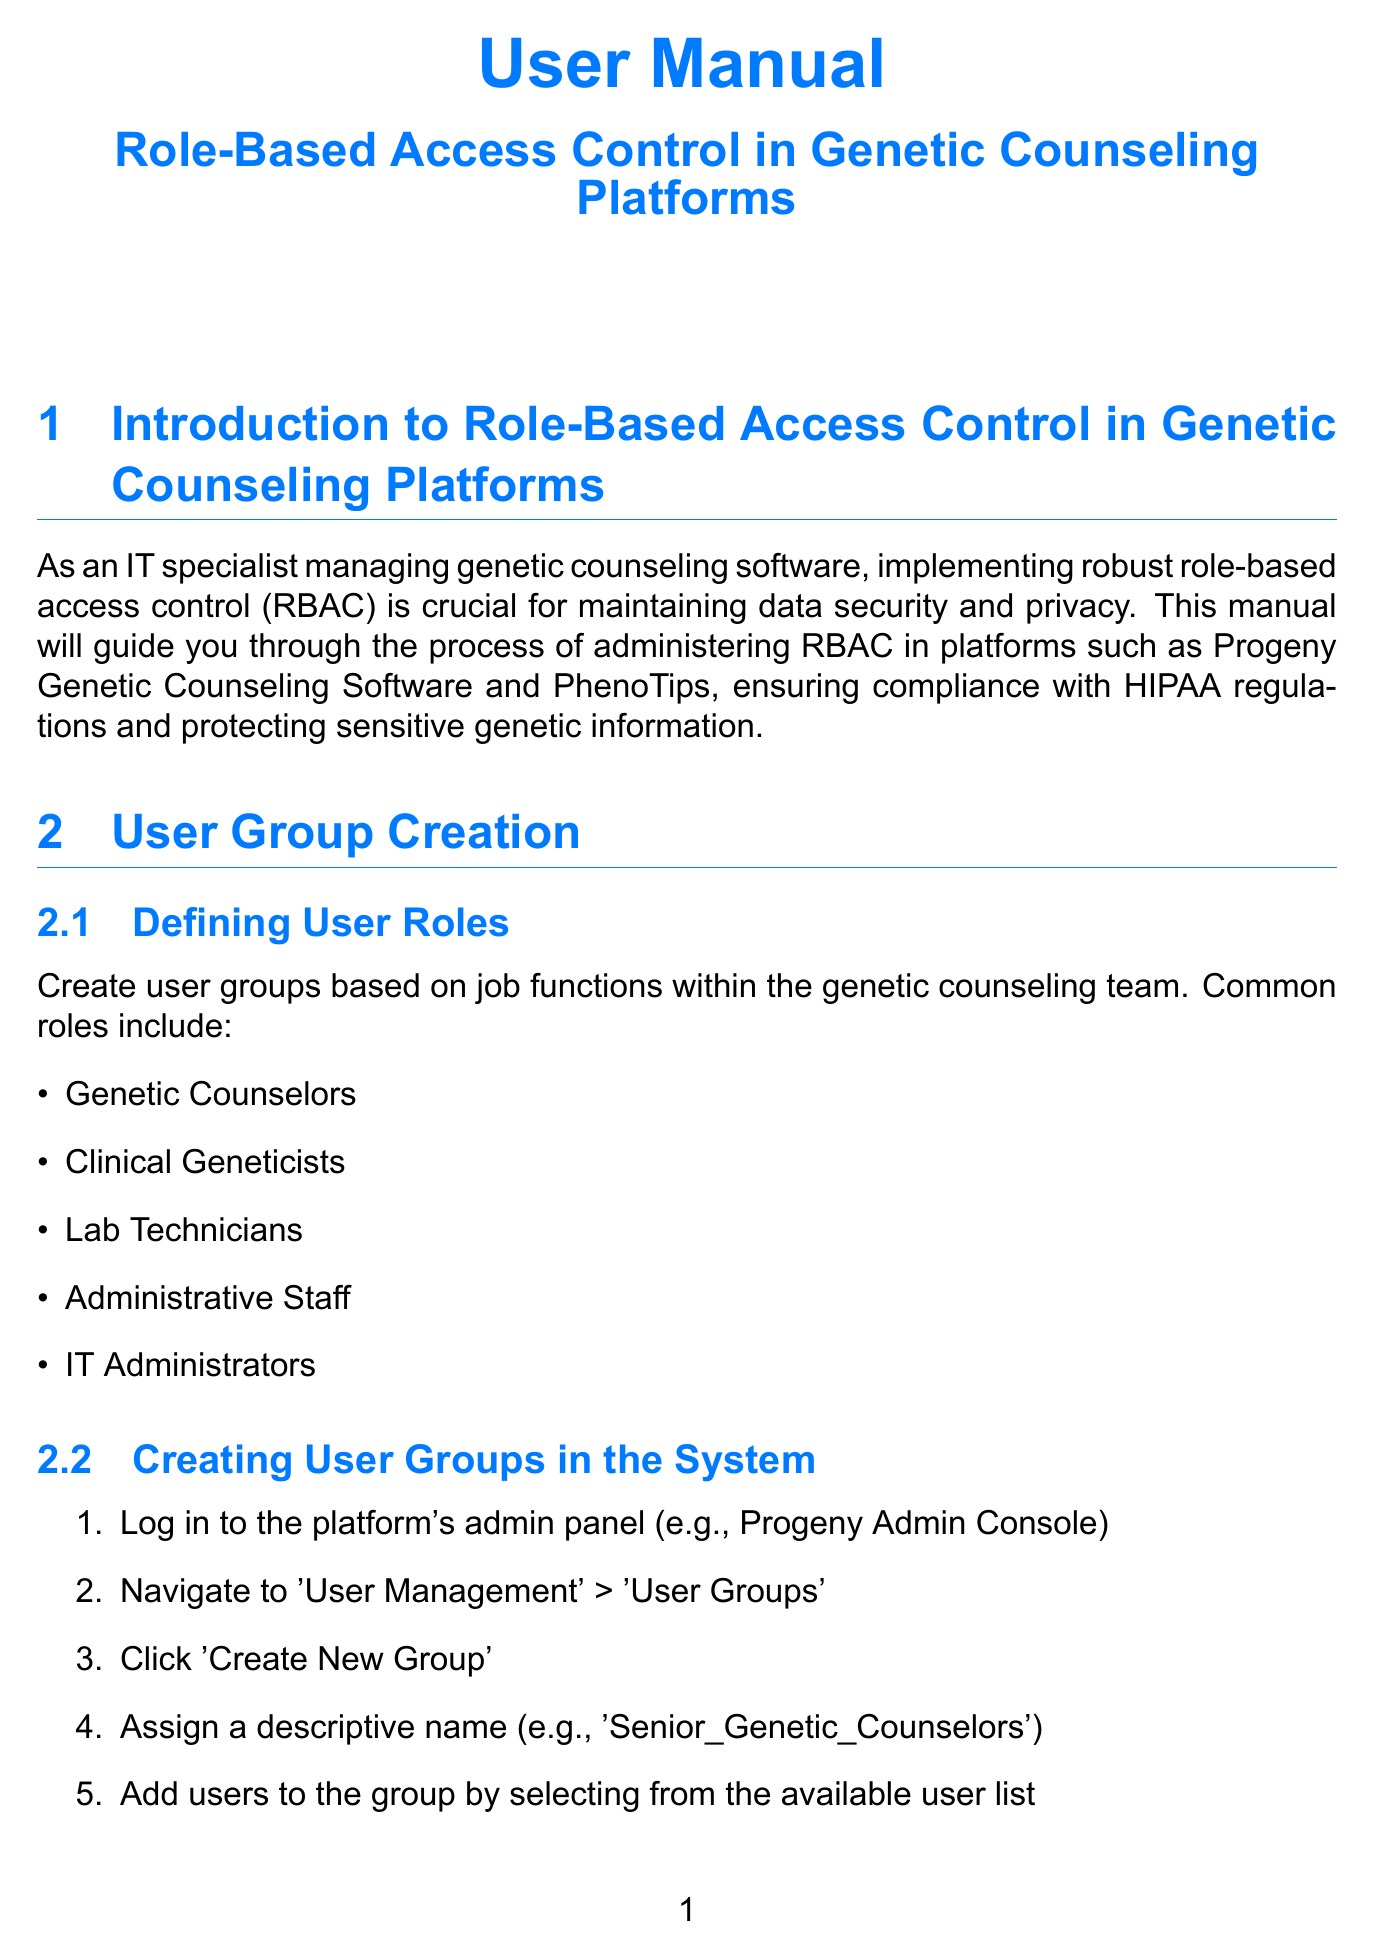What are the common roles defined for user groups? The document lists common roles such as Genetic Counselors, Clinical Geneticists, Lab Technicians, Administrative Staff, and IT Administrators.
Answer: Genetic Counselors, Clinical Geneticists, Lab Technicians, Administrative Staff, IT Administrators What should be done to enable comprehensive logging? To enable comprehensive logging, access the platform's configuration settings and enable logging for all user actions.
Answer: Enable logging for all user actions How many years is the retention period for audit logs for HIPAA compliance? The document specifies a retention period of 7 years for audit logs to comply with HIPAA regulations.
Answer: 7 years What is the first step in creating user groups in the system? The first step is to log in to the platform's admin panel, for example, the Progeny Admin Console.
Answer: Log in to the platform's admin panel What does RBAC stand for? The abbreviation RBAC stands for Role-Based Access Control, which is a system for managing user permissions.
Answer: Role-Based Access Control What is the purpose of setting up alerts in audit trail management? The alerts are configured to notify the IT security team of suspicious activities like multiple failed login attempts.
Answer: Notify of suspicious activities Which integration methods are suggested for user management across platforms? The document suggests configuring SAML or OAuth 2.0 integration with the organization's identity provider.
Answer: SAML or OAuth 2.0 What is a major feature of the regular review and maintenance process? A major feature is conducting quarterly reviews of user access rights to ensure continued security and compliance.
Answer: Conduct quarterly reviews of user access rights 